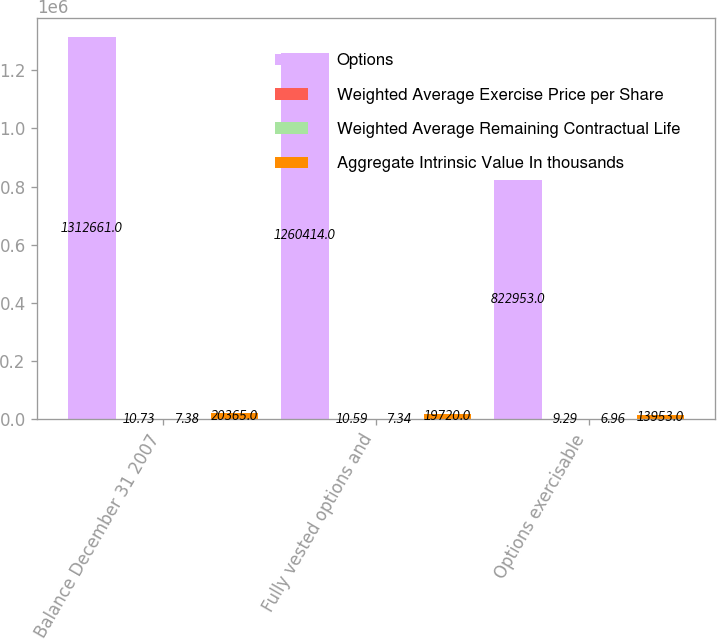Convert chart to OTSL. <chart><loc_0><loc_0><loc_500><loc_500><stacked_bar_chart><ecel><fcel>Balance December 31 2007<fcel>Fully vested options and<fcel>Options exercisable<nl><fcel>Options<fcel>1.31266e+06<fcel>1.26041e+06<fcel>822953<nl><fcel>Weighted Average Exercise Price per Share<fcel>10.73<fcel>10.59<fcel>9.29<nl><fcel>Weighted Average Remaining Contractual Life<fcel>7.38<fcel>7.34<fcel>6.96<nl><fcel>Aggregate Intrinsic Value In thousands<fcel>20365<fcel>19720<fcel>13953<nl></chart> 